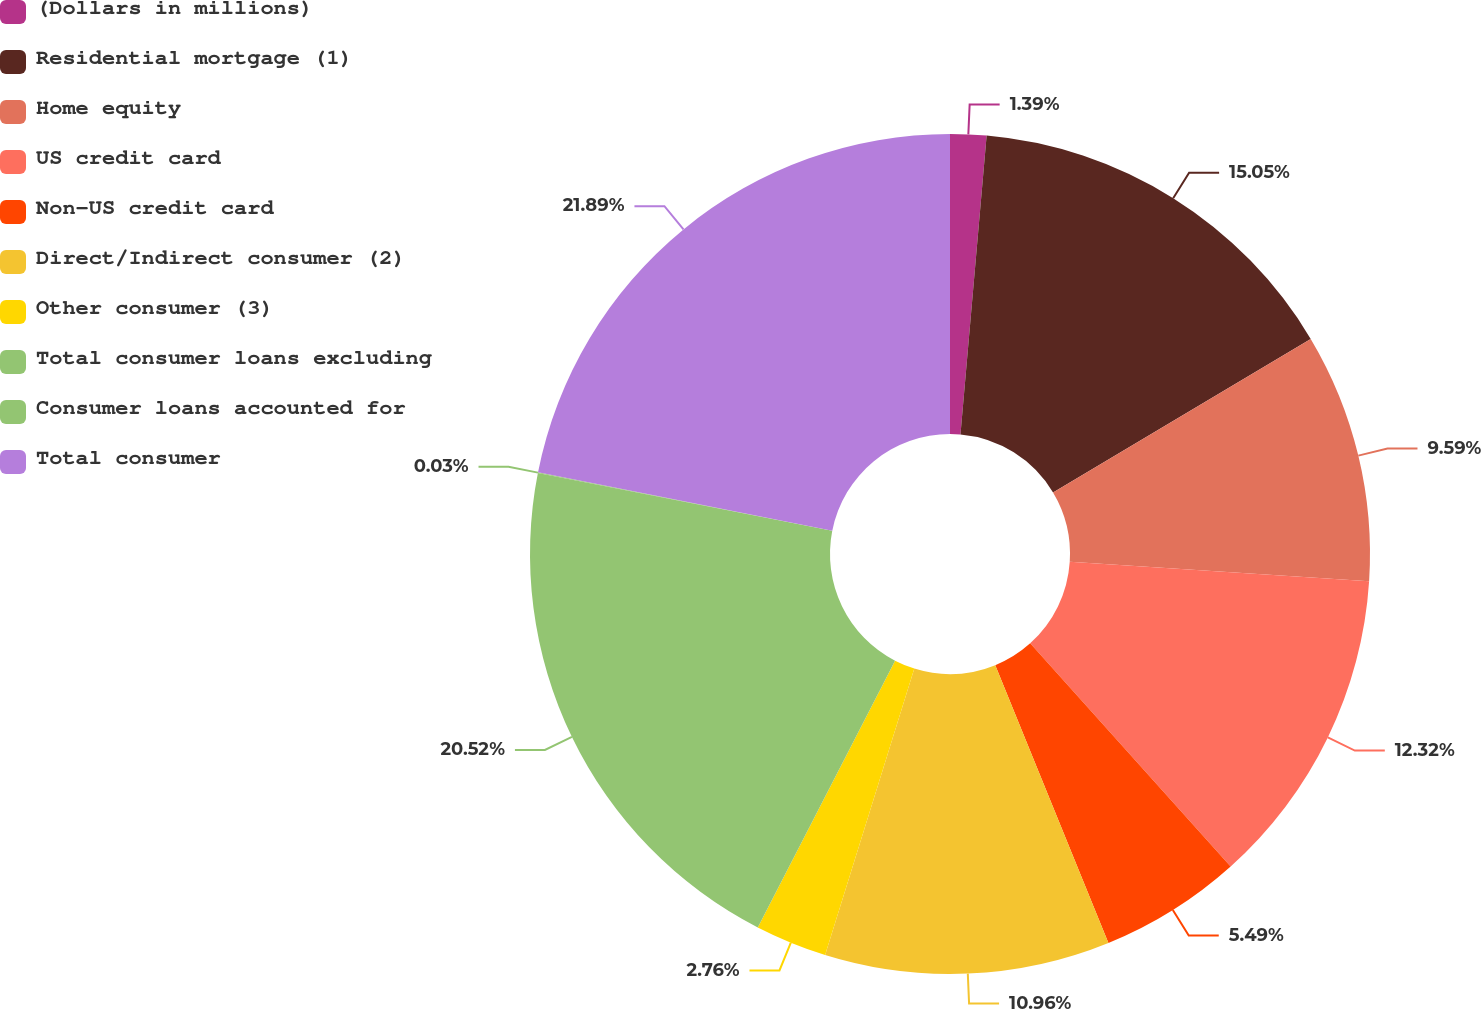<chart> <loc_0><loc_0><loc_500><loc_500><pie_chart><fcel>(Dollars in millions)<fcel>Residential mortgage (1)<fcel>Home equity<fcel>US credit card<fcel>Non-US credit card<fcel>Direct/Indirect consumer (2)<fcel>Other consumer (3)<fcel>Total consumer loans excluding<fcel>Consumer loans accounted for<fcel>Total consumer<nl><fcel>1.39%<fcel>15.05%<fcel>9.59%<fcel>12.32%<fcel>5.49%<fcel>10.96%<fcel>2.76%<fcel>20.52%<fcel>0.03%<fcel>21.88%<nl></chart> 